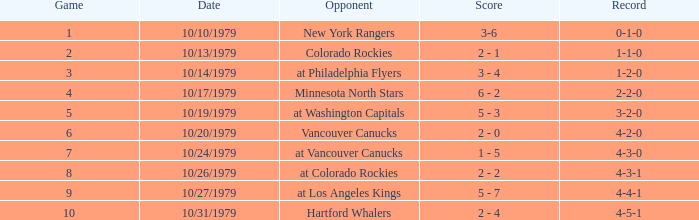Could you parse the entire table? {'header': ['Game', 'Date', 'Opponent', 'Score', 'Record'], 'rows': [['1', '10/10/1979', 'New York Rangers', '3-6', '0-1-0'], ['2', '10/13/1979', 'Colorado Rockies', '2 - 1', '1-1-0'], ['3', '10/14/1979', 'at Philadelphia Flyers', '3 - 4', '1-2-0'], ['4', '10/17/1979', 'Minnesota North Stars', '6 - 2', '2-2-0'], ['5', '10/19/1979', 'at Washington Capitals', '5 - 3', '3-2-0'], ['6', '10/20/1979', 'Vancouver Canucks', '2 - 0', '4-2-0'], ['7', '10/24/1979', 'at Vancouver Canucks', '1 - 5', '4-3-0'], ['8', '10/26/1979', 'at Colorado Rockies', '2 - 2', '4-3-1'], ['9', '10/27/1979', 'at Los Angeles Kings', '5 - 7', '4-4-1'], ['10', '10/31/1979', 'Hartford Whalers', '2 - 4', '4-5-1']]} What is the date associated with the 4-3-0 record? 10/24/1979. 